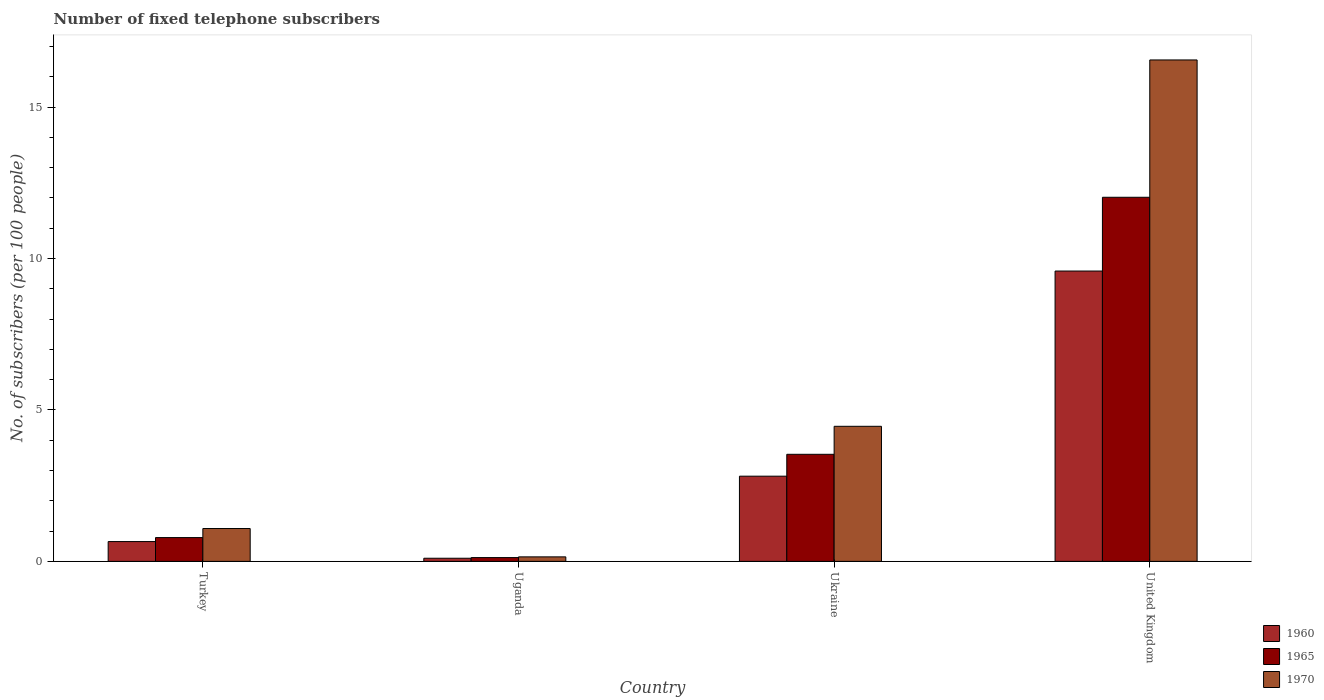How many different coloured bars are there?
Provide a short and direct response. 3. Are the number of bars per tick equal to the number of legend labels?
Provide a short and direct response. Yes. Are the number of bars on each tick of the X-axis equal?
Make the answer very short. Yes. How many bars are there on the 2nd tick from the left?
Offer a very short reply. 3. How many bars are there on the 1st tick from the right?
Your response must be concise. 3. What is the label of the 2nd group of bars from the left?
Give a very brief answer. Uganda. What is the number of fixed telephone subscribers in 1965 in Uganda?
Your answer should be compact. 0.12. Across all countries, what is the maximum number of fixed telephone subscribers in 1965?
Make the answer very short. 12.02. Across all countries, what is the minimum number of fixed telephone subscribers in 1965?
Your response must be concise. 0.12. In which country was the number of fixed telephone subscribers in 1960 maximum?
Offer a terse response. United Kingdom. In which country was the number of fixed telephone subscribers in 1970 minimum?
Provide a succinct answer. Uganda. What is the total number of fixed telephone subscribers in 1970 in the graph?
Offer a terse response. 22.25. What is the difference between the number of fixed telephone subscribers in 1960 in Ukraine and that in United Kingdom?
Ensure brevity in your answer.  -6.77. What is the difference between the number of fixed telephone subscribers in 1965 in Ukraine and the number of fixed telephone subscribers in 1960 in Turkey?
Ensure brevity in your answer.  2.88. What is the average number of fixed telephone subscribers in 1970 per country?
Ensure brevity in your answer.  5.56. What is the difference between the number of fixed telephone subscribers of/in 1965 and number of fixed telephone subscribers of/in 1970 in United Kingdom?
Keep it short and to the point. -4.53. What is the ratio of the number of fixed telephone subscribers in 1965 in Ukraine to that in United Kingdom?
Make the answer very short. 0.29. What is the difference between the highest and the second highest number of fixed telephone subscribers in 1960?
Offer a terse response. -8.93. What is the difference between the highest and the lowest number of fixed telephone subscribers in 1965?
Provide a succinct answer. 11.9. In how many countries, is the number of fixed telephone subscribers in 1970 greater than the average number of fixed telephone subscribers in 1970 taken over all countries?
Keep it short and to the point. 1. What does the 1st bar from the right in Turkey represents?
Offer a terse response. 1970. How many bars are there?
Make the answer very short. 12. Are all the bars in the graph horizontal?
Keep it short and to the point. No. How many countries are there in the graph?
Keep it short and to the point. 4. What is the difference between two consecutive major ticks on the Y-axis?
Provide a succinct answer. 5. Are the values on the major ticks of Y-axis written in scientific E-notation?
Keep it short and to the point. No. Does the graph contain grids?
Keep it short and to the point. No. How many legend labels are there?
Give a very brief answer. 3. How are the legend labels stacked?
Your answer should be very brief. Vertical. What is the title of the graph?
Ensure brevity in your answer.  Number of fixed telephone subscribers. Does "2005" appear as one of the legend labels in the graph?
Your response must be concise. No. What is the label or title of the X-axis?
Offer a terse response. Country. What is the label or title of the Y-axis?
Give a very brief answer. No. of subscribers (per 100 people). What is the No. of subscribers (per 100 people) in 1960 in Turkey?
Keep it short and to the point. 0.65. What is the No. of subscribers (per 100 people) of 1965 in Turkey?
Ensure brevity in your answer.  0.79. What is the No. of subscribers (per 100 people) in 1970 in Turkey?
Your answer should be compact. 1.08. What is the No. of subscribers (per 100 people) in 1960 in Uganda?
Your answer should be very brief. 0.1. What is the No. of subscribers (per 100 people) in 1965 in Uganda?
Your answer should be compact. 0.12. What is the No. of subscribers (per 100 people) in 1970 in Uganda?
Offer a terse response. 0.15. What is the No. of subscribers (per 100 people) of 1960 in Ukraine?
Provide a short and direct response. 2.81. What is the No. of subscribers (per 100 people) of 1965 in Ukraine?
Your response must be concise. 3.53. What is the No. of subscribers (per 100 people) of 1970 in Ukraine?
Provide a short and direct response. 4.46. What is the No. of subscribers (per 100 people) in 1960 in United Kingdom?
Give a very brief answer. 9.59. What is the No. of subscribers (per 100 people) of 1965 in United Kingdom?
Provide a succinct answer. 12.02. What is the No. of subscribers (per 100 people) of 1970 in United Kingdom?
Provide a short and direct response. 16.56. Across all countries, what is the maximum No. of subscribers (per 100 people) of 1960?
Ensure brevity in your answer.  9.59. Across all countries, what is the maximum No. of subscribers (per 100 people) of 1965?
Your response must be concise. 12.02. Across all countries, what is the maximum No. of subscribers (per 100 people) in 1970?
Give a very brief answer. 16.56. Across all countries, what is the minimum No. of subscribers (per 100 people) in 1960?
Offer a very short reply. 0.1. Across all countries, what is the minimum No. of subscribers (per 100 people) in 1965?
Your response must be concise. 0.12. Across all countries, what is the minimum No. of subscribers (per 100 people) in 1970?
Offer a terse response. 0.15. What is the total No. of subscribers (per 100 people) of 1960 in the graph?
Your answer should be very brief. 13.16. What is the total No. of subscribers (per 100 people) in 1965 in the graph?
Make the answer very short. 16.47. What is the total No. of subscribers (per 100 people) in 1970 in the graph?
Offer a very short reply. 22.25. What is the difference between the No. of subscribers (per 100 people) in 1960 in Turkey and that in Uganda?
Provide a succinct answer. 0.55. What is the difference between the No. of subscribers (per 100 people) of 1965 in Turkey and that in Uganda?
Keep it short and to the point. 0.66. What is the difference between the No. of subscribers (per 100 people) of 1970 in Turkey and that in Uganda?
Make the answer very short. 0.94. What is the difference between the No. of subscribers (per 100 people) in 1960 in Turkey and that in Ukraine?
Provide a short and direct response. -2.16. What is the difference between the No. of subscribers (per 100 people) of 1965 in Turkey and that in Ukraine?
Provide a short and direct response. -2.75. What is the difference between the No. of subscribers (per 100 people) in 1970 in Turkey and that in Ukraine?
Offer a terse response. -3.38. What is the difference between the No. of subscribers (per 100 people) of 1960 in Turkey and that in United Kingdom?
Your response must be concise. -8.93. What is the difference between the No. of subscribers (per 100 people) of 1965 in Turkey and that in United Kingdom?
Make the answer very short. -11.24. What is the difference between the No. of subscribers (per 100 people) of 1970 in Turkey and that in United Kingdom?
Provide a succinct answer. -15.47. What is the difference between the No. of subscribers (per 100 people) of 1960 in Uganda and that in Ukraine?
Your response must be concise. -2.71. What is the difference between the No. of subscribers (per 100 people) of 1965 in Uganda and that in Ukraine?
Offer a terse response. -3.41. What is the difference between the No. of subscribers (per 100 people) in 1970 in Uganda and that in Ukraine?
Make the answer very short. -4.31. What is the difference between the No. of subscribers (per 100 people) of 1960 in Uganda and that in United Kingdom?
Provide a succinct answer. -9.48. What is the difference between the No. of subscribers (per 100 people) of 1965 in Uganda and that in United Kingdom?
Make the answer very short. -11.9. What is the difference between the No. of subscribers (per 100 people) in 1970 in Uganda and that in United Kingdom?
Make the answer very short. -16.41. What is the difference between the No. of subscribers (per 100 people) of 1960 in Ukraine and that in United Kingdom?
Give a very brief answer. -6.77. What is the difference between the No. of subscribers (per 100 people) of 1965 in Ukraine and that in United Kingdom?
Your answer should be compact. -8.49. What is the difference between the No. of subscribers (per 100 people) in 1970 in Ukraine and that in United Kingdom?
Ensure brevity in your answer.  -12.1. What is the difference between the No. of subscribers (per 100 people) of 1960 in Turkey and the No. of subscribers (per 100 people) of 1965 in Uganda?
Offer a very short reply. 0.53. What is the difference between the No. of subscribers (per 100 people) of 1960 in Turkey and the No. of subscribers (per 100 people) of 1970 in Uganda?
Offer a very short reply. 0.51. What is the difference between the No. of subscribers (per 100 people) of 1965 in Turkey and the No. of subscribers (per 100 people) of 1970 in Uganda?
Your response must be concise. 0.64. What is the difference between the No. of subscribers (per 100 people) of 1960 in Turkey and the No. of subscribers (per 100 people) of 1965 in Ukraine?
Your answer should be compact. -2.88. What is the difference between the No. of subscribers (per 100 people) of 1960 in Turkey and the No. of subscribers (per 100 people) of 1970 in Ukraine?
Give a very brief answer. -3.81. What is the difference between the No. of subscribers (per 100 people) in 1965 in Turkey and the No. of subscribers (per 100 people) in 1970 in Ukraine?
Offer a terse response. -3.67. What is the difference between the No. of subscribers (per 100 people) of 1960 in Turkey and the No. of subscribers (per 100 people) of 1965 in United Kingdom?
Provide a short and direct response. -11.37. What is the difference between the No. of subscribers (per 100 people) in 1960 in Turkey and the No. of subscribers (per 100 people) in 1970 in United Kingdom?
Make the answer very short. -15.9. What is the difference between the No. of subscribers (per 100 people) of 1965 in Turkey and the No. of subscribers (per 100 people) of 1970 in United Kingdom?
Your response must be concise. -15.77. What is the difference between the No. of subscribers (per 100 people) of 1960 in Uganda and the No. of subscribers (per 100 people) of 1965 in Ukraine?
Offer a very short reply. -3.43. What is the difference between the No. of subscribers (per 100 people) in 1960 in Uganda and the No. of subscribers (per 100 people) in 1970 in Ukraine?
Your answer should be compact. -4.36. What is the difference between the No. of subscribers (per 100 people) of 1965 in Uganda and the No. of subscribers (per 100 people) of 1970 in Ukraine?
Ensure brevity in your answer.  -4.34. What is the difference between the No. of subscribers (per 100 people) of 1960 in Uganda and the No. of subscribers (per 100 people) of 1965 in United Kingdom?
Offer a terse response. -11.92. What is the difference between the No. of subscribers (per 100 people) of 1960 in Uganda and the No. of subscribers (per 100 people) of 1970 in United Kingdom?
Your answer should be compact. -16.45. What is the difference between the No. of subscribers (per 100 people) in 1965 in Uganda and the No. of subscribers (per 100 people) in 1970 in United Kingdom?
Provide a short and direct response. -16.43. What is the difference between the No. of subscribers (per 100 people) of 1960 in Ukraine and the No. of subscribers (per 100 people) of 1965 in United Kingdom?
Your answer should be compact. -9.21. What is the difference between the No. of subscribers (per 100 people) in 1960 in Ukraine and the No. of subscribers (per 100 people) in 1970 in United Kingdom?
Ensure brevity in your answer.  -13.74. What is the difference between the No. of subscribers (per 100 people) in 1965 in Ukraine and the No. of subscribers (per 100 people) in 1970 in United Kingdom?
Make the answer very short. -13.02. What is the average No. of subscribers (per 100 people) in 1960 per country?
Provide a succinct answer. 3.29. What is the average No. of subscribers (per 100 people) in 1965 per country?
Your response must be concise. 4.12. What is the average No. of subscribers (per 100 people) in 1970 per country?
Your answer should be very brief. 5.56. What is the difference between the No. of subscribers (per 100 people) in 1960 and No. of subscribers (per 100 people) in 1965 in Turkey?
Offer a very short reply. -0.13. What is the difference between the No. of subscribers (per 100 people) of 1960 and No. of subscribers (per 100 people) of 1970 in Turkey?
Keep it short and to the point. -0.43. What is the difference between the No. of subscribers (per 100 people) in 1965 and No. of subscribers (per 100 people) in 1970 in Turkey?
Keep it short and to the point. -0.3. What is the difference between the No. of subscribers (per 100 people) of 1960 and No. of subscribers (per 100 people) of 1965 in Uganda?
Offer a terse response. -0.02. What is the difference between the No. of subscribers (per 100 people) in 1960 and No. of subscribers (per 100 people) in 1970 in Uganda?
Make the answer very short. -0.05. What is the difference between the No. of subscribers (per 100 people) in 1965 and No. of subscribers (per 100 people) in 1970 in Uganda?
Provide a succinct answer. -0.02. What is the difference between the No. of subscribers (per 100 people) of 1960 and No. of subscribers (per 100 people) of 1965 in Ukraine?
Offer a terse response. -0.72. What is the difference between the No. of subscribers (per 100 people) in 1960 and No. of subscribers (per 100 people) in 1970 in Ukraine?
Your answer should be compact. -1.65. What is the difference between the No. of subscribers (per 100 people) of 1965 and No. of subscribers (per 100 people) of 1970 in Ukraine?
Provide a succinct answer. -0.92. What is the difference between the No. of subscribers (per 100 people) of 1960 and No. of subscribers (per 100 people) of 1965 in United Kingdom?
Ensure brevity in your answer.  -2.44. What is the difference between the No. of subscribers (per 100 people) in 1960 and No. of subscribers (per 100 people) in 1970 in United Kingdom?
Give a very brief answer. -6.97. What is the difference between the No. of subscribers (per 100 people) of 1965 and No. of subscribers (per 100 people) of 1970 in United Kingdom?
Give a very brief answer. -4.53. What is the ratio of the No. of subscribers (per 100 people) in 1960 in Turkey to that in Uganda?
Keep it short and to the point. 6.34. What is the ratio of the No. of subscribers (per 100 people) in 1965 in Turkey to that in Uganda?
Your response must be concise. 6.29. What is the ratio of the No. of subscribers (per 100 people) in 1970 in Turkey to that in Uganda?
Ensure brevity in your answer.  7.32. What is the ratio of the No. of subscribers (per 100 people) in 1960 in Turkey to that in Ukraine?
Provide a succinct answer. 0.23. What is the ratio of the No. of subscribers (per 100 people) of 1965 in Turkey to that in Ukraine?
Make the answer very short. 0.22. What is the ratio of the No. of subscribers (per 100 people) of 1970 in Turkey to that in Ukraine?
Your answer should be compact. 0.24. What is the ratio of the No. of subscribers (per 100 people) of 1960 in Turkey to that in United Kingdom?
Your answer should be compact. 0.07. What is the ratio of the No. of subscribers (per 100 people) of 1965 in Turkey to that in United Kingdom?
Offer a very short reply. 0.07. What is the ratio of the No. of subscribers (per 100 people) of 1970 in Turkey to that in United Kingdom?
Offer a very short reply. 0.07. What is the ratio of the No. of subscribers (per 100 people) in 1960 in Uganda to that in Ukraine?
Make the answer very short. 0.04. What is the ratio of the No. of subscribers (per 100 people) of 1965 in Uganda to that in Ukraine?
Offer a terse response. 0.04. What is the ratio of the No. of subscribers (per 100 people) of 1970 in Uganda to that in Ukraine?
Ensure brevity in your answer.  0.03. What is the ratio of the No. of subscribers (per 100 people) in 1960 in Uganda to that in United Kingdom?
Your answer should be very brief. 0.01. What is the ratio of the No. of subscribers (per 100 people) in 1965 in Uganda to that in United Kingdom?
Your answer should be very brief. 0.01. What is the ratio of the No. of subscribers (per 100 people) of 1970 in Uganda to that in United Kingdom?
Provide a succinct answer. 0.01. What is the ratio of the No. of subscribers (per 100 people) of 1960 in Ukraine to that in United Kingdom?
Your response must be concise. 0.29. What is the ratio of the No. of subscribers (per 100 people) in 1965 in Ukraine to that in United Kingdom?
Offer a terse response. 0.29. What is the ratio of the No. of subscribers (per 100 people) of 1970 in Ukraine to that in United Kingdom?
Offer a terse response. 0.27. What is the difference between the highest and the second highest No. of subscribers (per 100 people) of 1960?
Provide a succinct answer. 6.77. What is the difference between the highest and the second highest No. of subscribers (per 100 people) in 1965?
Provide a short and direct response. 8.49. What is the difference between the highest and the second highest No. of subscribers (per 100 people) of 1970?
Your response must be concise. 12.1. What is the difference between the highest and the lowest No. of subscribers (per 100 people) of 1960?
Your response must be concise. 9.48. What is the difference between the highest and the lowest No. of subscribers (per 100 people) of 1965?
Offer a terse response. 11.9. What is the difference between the highest and the lowest No. of subscribers (per 100 people) in 1970?
Keep it short and to the point. 16.41. 